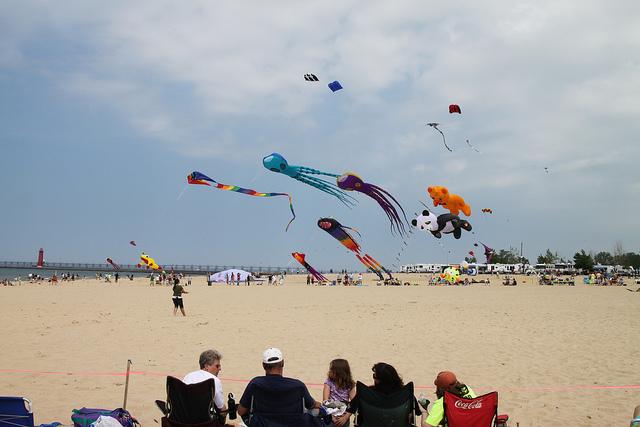What are these people flying?
Give a very brief answer. Kites. They are yellow?
Concise answer only. No. Who all is sitting on the ground?
Concise answer only. People. How many yellow kites are in the air?
Answer briefly. 1. What are the two brightly colored kites shaped to represent?
Keep it brief. Bears. What is in the background?
Be succinct. Kites. What types of clouds are in the sky?
Quick response, please. White. How many tails does the kite have?
Give a very brief answer. Many. Is this picture taken on the beach?
Short answer required. Yes. Are they at a balloon festival?
Short answer required. No. What sport is this?
Quick response, please. Kite flying. 